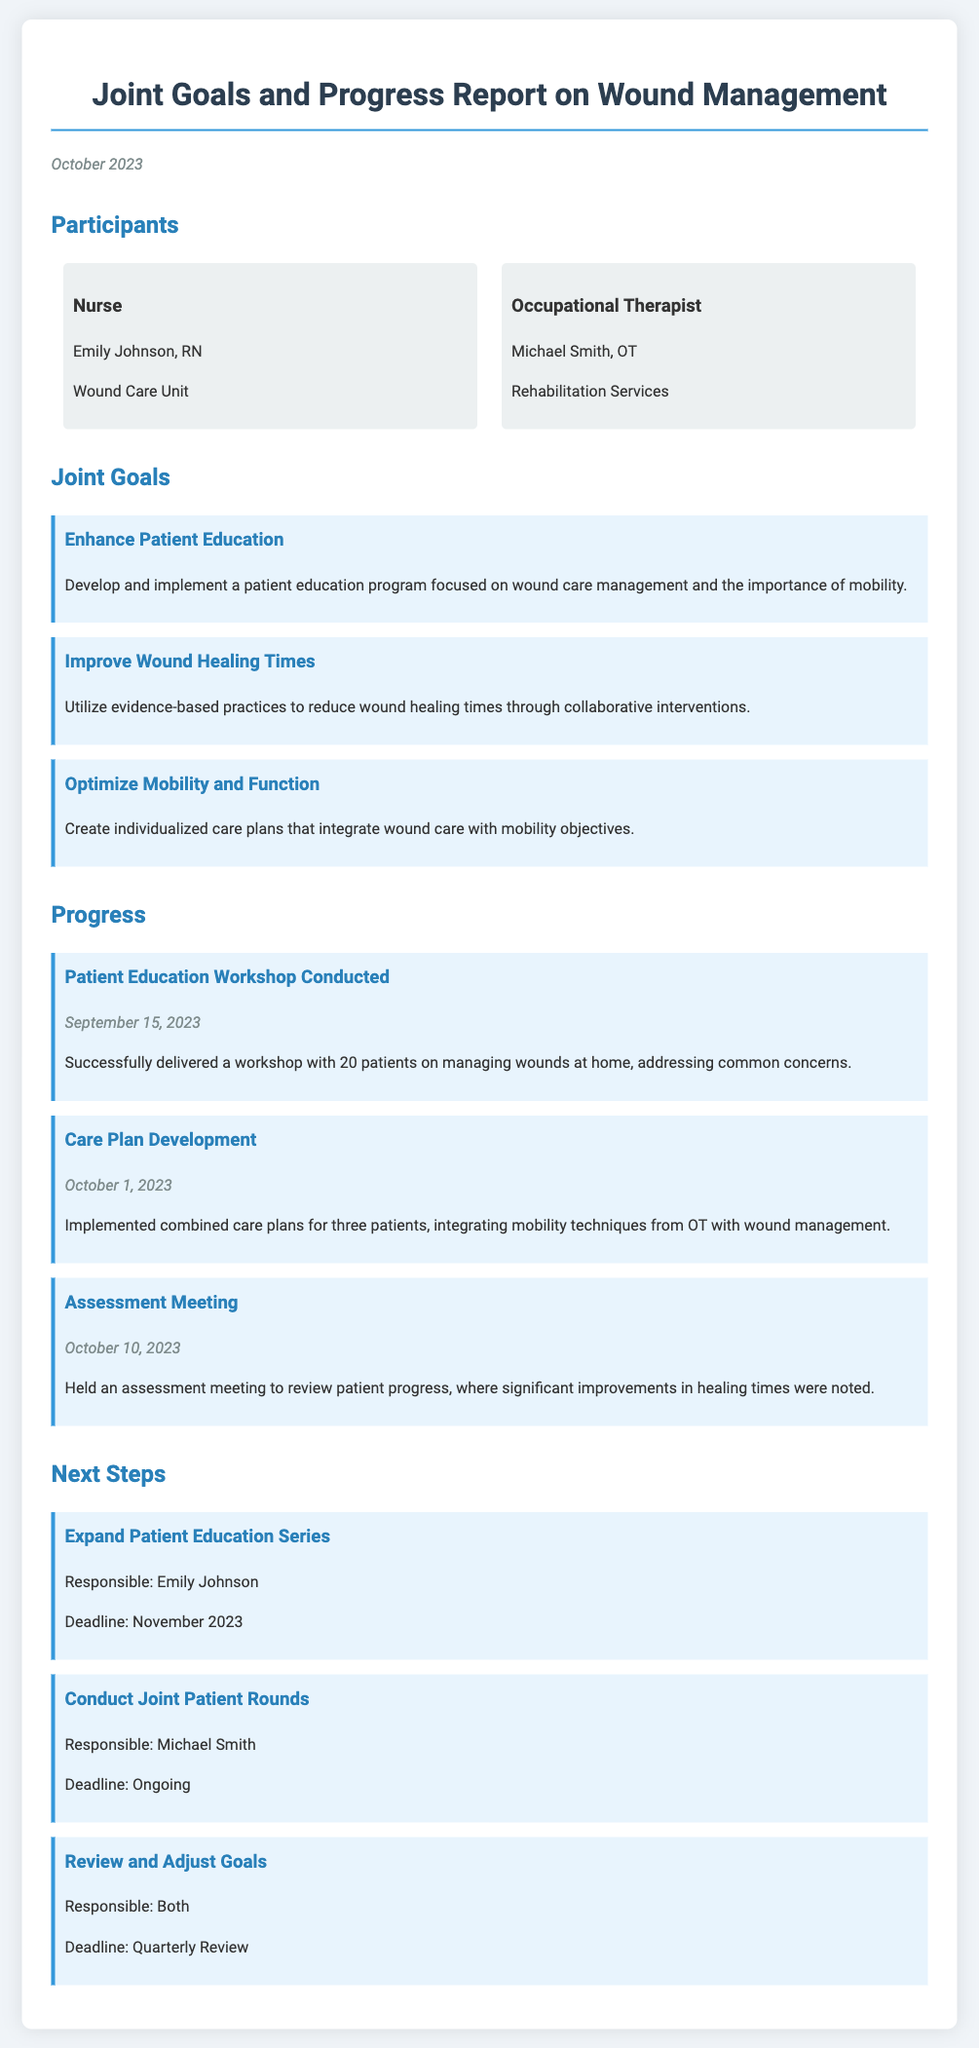What are the names of the participants? The participants listed are Emily Johnson, RN and Michael Smith, OT, representing nursing and occupational therapy respectively.
Answer: Emily Johnson, RN and Michael Smith, OT What was the date of the patient education workshop? The date of the workshop conducted was specified in the document as September 15, 2023.
Answer: September 15, 2023 What is one of the joint goals regarding mobility? The document mentions a specific goal about creating individualized care plans that integrate wound care with mobility objectives.
Answer: Optimize Mobility and Function When was the care plan development implemented? The date for the implementation of combined care plans for patients is recorded as October 1, 2023.
Answer: October 1, 2023 Who is responsible for expanding the patient education series? The document states that Emily Johnson is responsible for expanding the patient education series.
Answer: Emily Johnson What type of meeting was held on October 10, 2023? The document mentions that an assessment meeting was held to review patient progress on that date.
Answer: Assessment Meeting What is the deadline for conducting joint patient rounds? The document states that conducting joint patient rounds is an ongoing task without a specific deadline.
Answer: Ongoing How many patients attended the workshop? The document indicates that 20 patients attended the patient education workshop on managing wounds at home.
Answer: 20 patients 